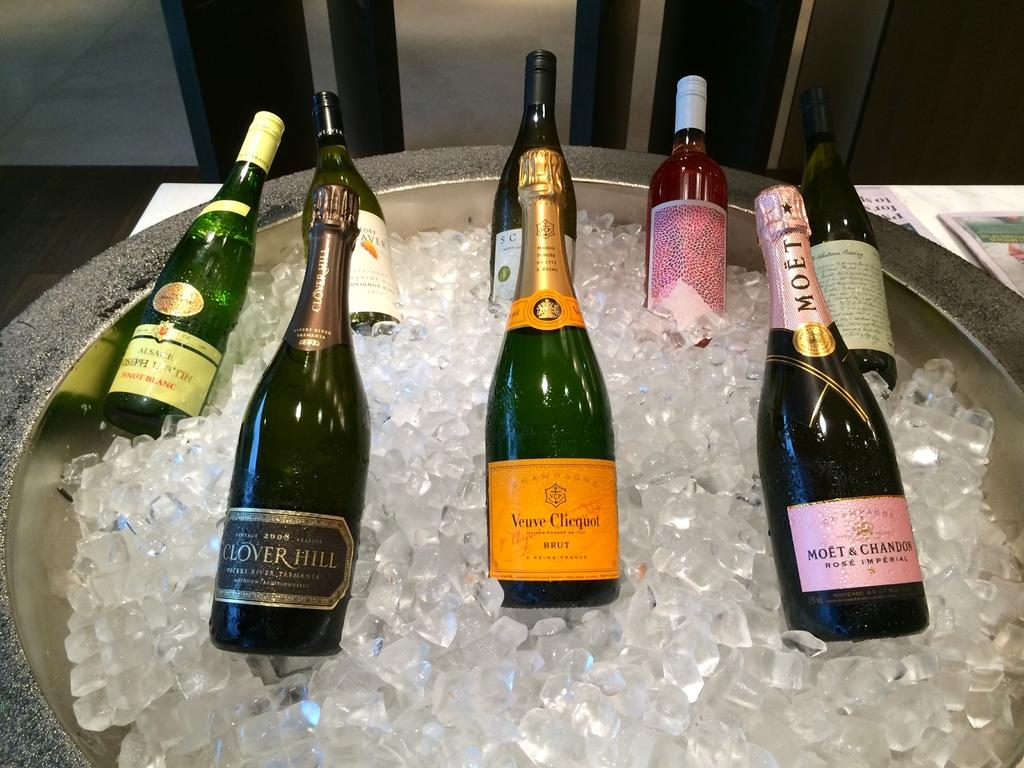<image>
Present a compact description of the photo's key features. tub of ice with champagne bottles in it including brut and clover hill 